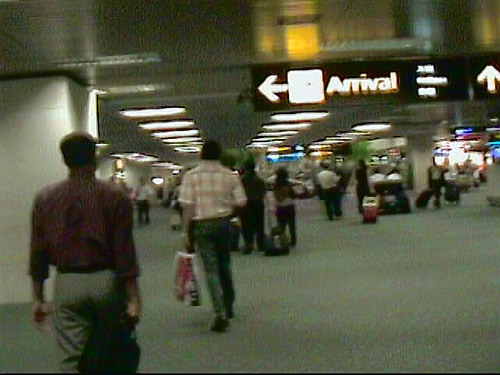<image>What is in the suitcase? I don't know what is in the suitcase. It could be clothes or papers. What is in the suitcase? It is unclear what is in the suitcase. It can contain clothes, papers, or other belongings. 